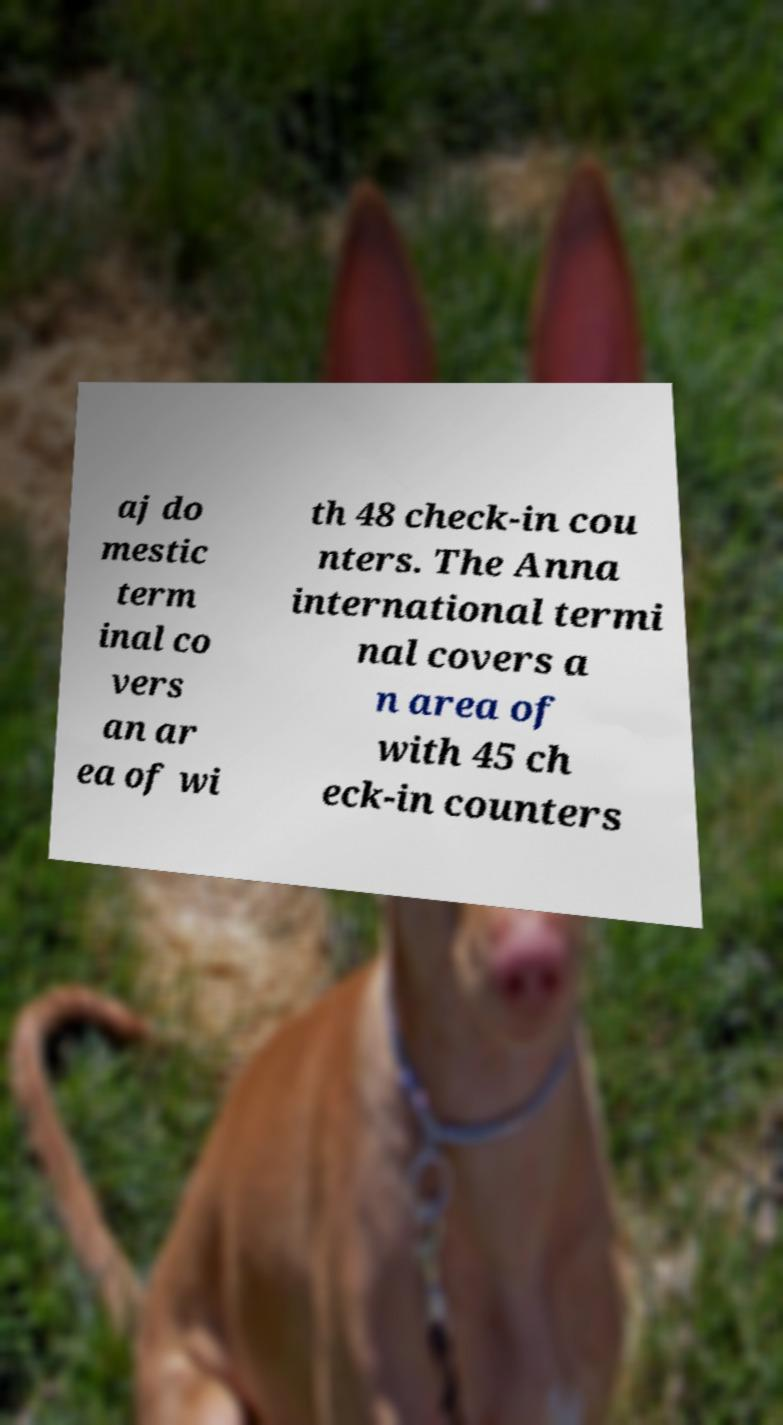Please identify and transcribe the text found in this image. aj do mestic term inal co vers an ar ea of wi th 48 check-in cou nters. The Anna international termi nal covers a n area of with 45 ch eck-in counters 